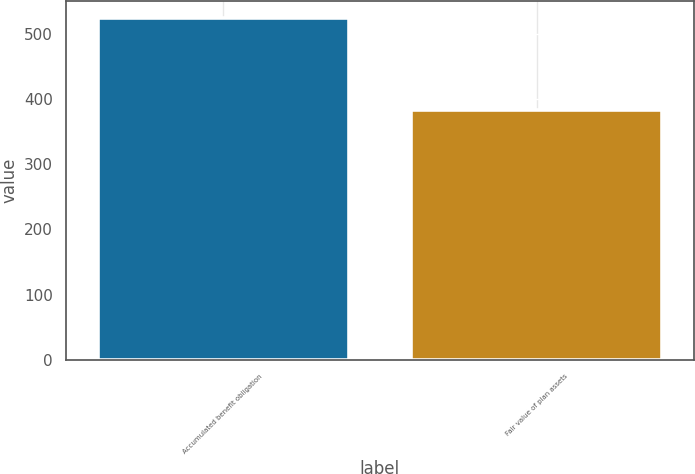<chart> <loc_0><loc_0><loc_500><loc_500><bar_chart><fcel>Accumulated benefit obligation<fcel>Fair value of plan assets<nl><fcel>524<fcel>383<nl></chart> 